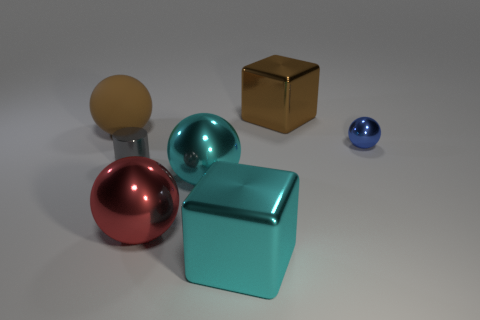Are the large red sphere in front of the small cylinder and the large cube behind the rubber ball made of the same material?
Offer a terse response. Yes. What shape is the other big thing that is the same color as the big rubber object?
Keep it short and to the point. Cube. How many red things are either tiny things or tiny rubber cylinders?
Make the answer very short. 0. What is the size of the gray shiny cylinder?
Your answer should be very brief. Small. Is the number of big cyan spheres that are left of the cyan block greater than the number of small green blocks?
Provide a succinct answer. Yes. There is a large brown cube; how many metallic things are in front of it?
Your answer should be compact. 5. Is there a brown rubber object that has the same size as the brown block?
Provide a succinct answer. Yes. What is the color of the other large metallic object that is the same shape as the brown metallic thing?
Ensure brevity in your answer.  Cyan. There is a cyan sphere behind the red metallic sphere; does it have the same size as the blue shiny sphere that is in front of the brown ball?
Keep it short and to the point. No. Is there a small shiny thing that has the same shape as the big brown matte object?
Offer a terse response. Yes. 